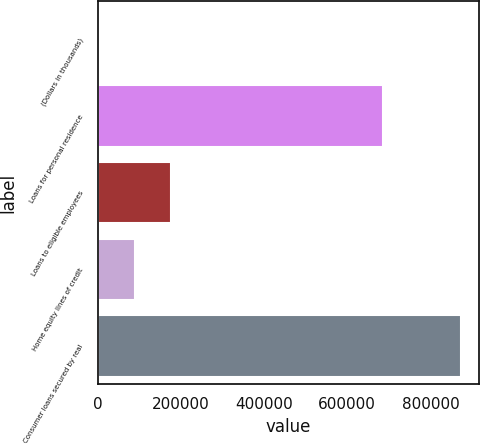Convert chart. <chart><loc_0><loc_0><loc_500><loc_500><bar_chart><fcel>(Dollars in thousands)<fcel>Loans for personal residence<fcel>Loans to eligible employees<fcel>Home equity lines of credit<fcel>Consumer loans secured by real<nl><fcel>2013<fcel>685327<fcel>176261<fcel>89137.2<fcel>873255<nl></chart> 